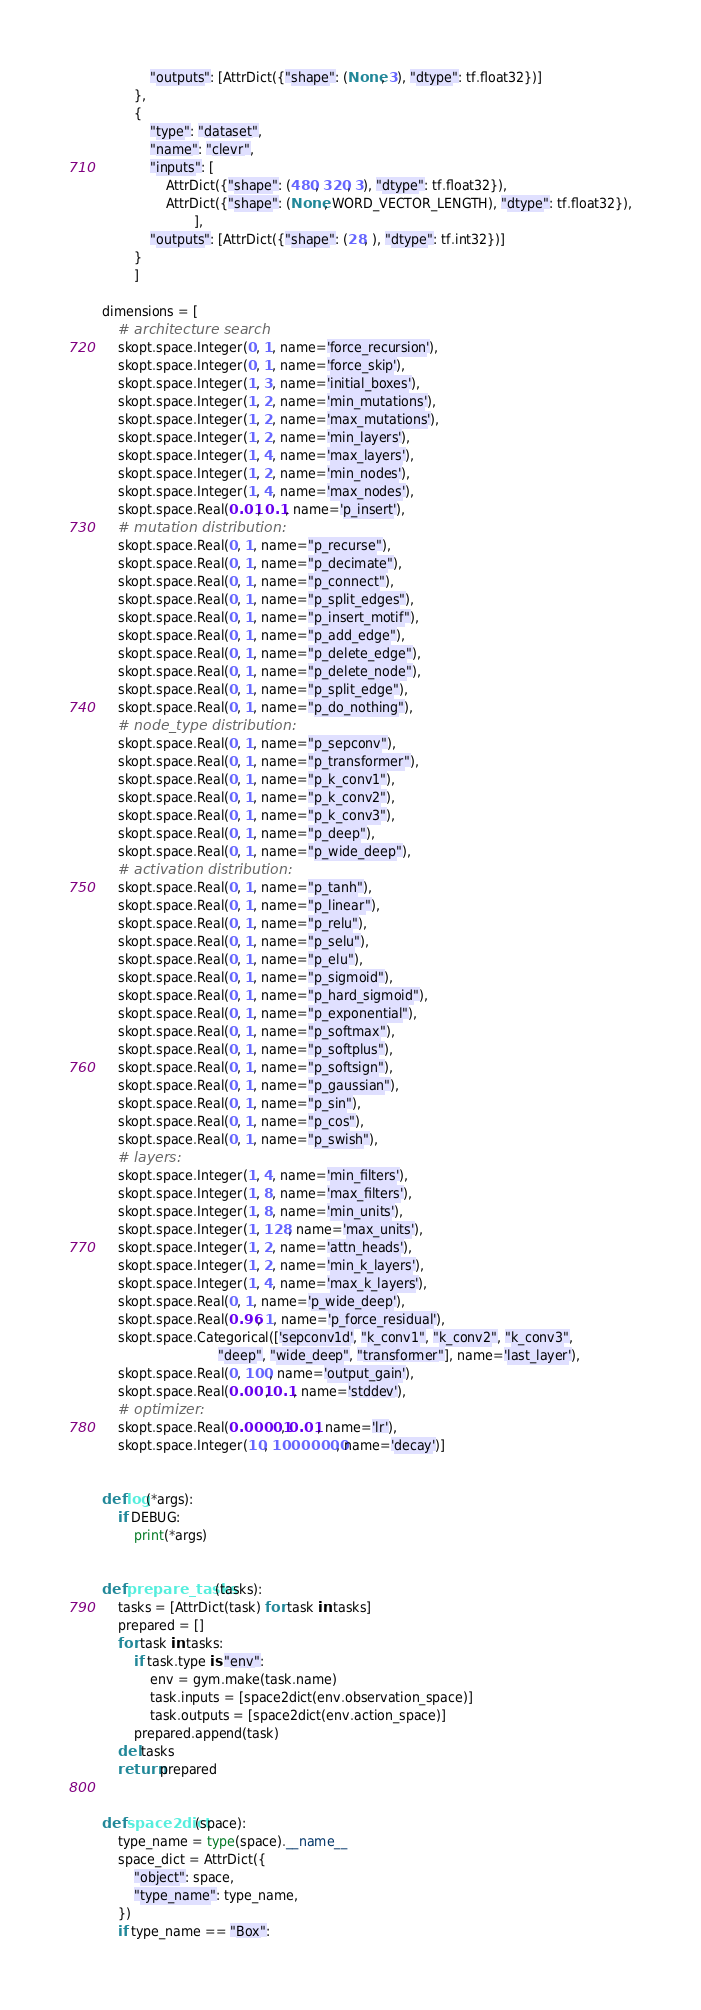<code> <loc_0><loc_0><loc_500><loc_500><_Python_>            "outputs": [AttrDict({"shape": (None, 3), "dtype": tf.float32})]
        },
        {
            "type": "dataset",
            "name": "clevr",
            "inputs": [
                AttrDict({"shape": (480, 320, 3), "dtype": tf.float32}),
                AttrDict({"shape": (None, WORD_VECTOR_LENGTH), "dtype": tf.float32}),
                       ],
            "outputs": [AttrDict({"shape": (28, ), "dtype": tf.int32})]
        }
        ]

dimensions = [
    # architecture search
    skopt.space.Integer(0, 1, name='force_recursion'),
    skopt.space.Integer(0, 1, name='force_skip'),
    skopt.space.Integer(1, 3, name='initial_boxes'),
    skopt.space.Integer(1, 2, name='min_mutations'),
    skopt.space.Integer(1, 2, name='max_mutations'),
    skopt.space.Integer(1, 2, name='min_layers'),
    skopt.space.Integer(1, 4, name='max_layers'),
    skopt.space.Integer(1, 2, name='min_nodes'),
    skopt.space.Integer(1, 4, name='max_nodes'),
    skopt.space.Real(0.01, 0.1, name='p_insert'),
    # mutation distribution:
    skopt.space.Real(0, 1, name="p_recurse"),
    skopt.space.Real(0, 1, name="p_decimate"),
    skopt.space.Real(0, 1, name="p_connect"),
    skopt.space.Real(0, 1, name="p_split_edges"),
    skopt.space.Real(0, 1, name="p_insert_motif"),
    skopt.space.Real(0, 1, name="p_add_edge"),
    skopt.space.Real(0, 1, name="p_delete_edge"),
    skopt.space.Real(0, 1, name="p_delete_node"),
    skopt.space.Real(0, 1, name="p_split_edge"),
    skopt.space.Real(0, 1, name="p_do_nothing"),
    # node_type distribution:
    skopt.space.Real(0, 1, name="p_sepconv"),
    skopt.space.Real(0, 1, name="p_transformer"),
    skopt.space.Real(0, 1, name="p_k_conv1"),
    skopt.space.Real(0, 1, name="p_k_conv2"),
    skopt.space.Real(0, 1, name="p_k_conv3"),
    skopt.space.Real(0, 1, name="p_deep"),
    skopt.space.Real(0, 1, name="p_wide_deep"),
    # activation distribution:
    skopt.space.Real(0, 1, name="p_tanh"),
    skopt.space.Real(0, 1, name="p_linear"),
    skopt.space.Real(0, 1, name="p_relu"),
    skopt.space.Real(0, 1, name="p_selu"),
    skopt.space.Real(0, 1, name="p_elu"),
    skopt.space.Real(0, 1, name="p_sigmoid"),
    skopt.space.Real(0, 1, name="p_hard_sigmoid"),
    skopt.space.Real(0, 1, name="p_exponential"),
    skopt.space.Real(0, 1, name="p_softmax"),
    skopt.space.Real(0, 1, name="p_softplus"),
    skopt.space.Real(0, 1, name="p_softsign"),
    skopt.space.Real(0, 1, name="p_gaussian"),
    skopt.space.Real(0, 1, name="p_sin"),
    skopt.space.Real(0, 1, name="p_cos"),
    skopt.space.Real(0, 1, name="p_swish"),
    # layers:
    skopt.space.Integer(1, 4, name='min_filters'),
    skopt.space.Integer(1, 8, name='max_filters'),
    skopt.space.Integer(1, 8, name='min_units'),
    skopt.space.Integer(1, 128, name='max_units'),
    skopt.space.Integer(1, 2, name='attn_heads'),
    skopt.space.Integer(1, 2, name='min_k_layers'),
    skopt.space.Integer(1, 4, name='max_k_layers'),
    skopt.space.Real(0, 1, name='p_wide_deep'),
    skopt.space.Real(0.96, 1, name='p_force_residual'),
    skopt.space.Categorical(['sepconv1d', "k_conv1", "k_conv2", "k_conv3",
                             "deep", "wide_deep", "transformer"], name='last_layer'),
    skopt.space.Real(0, 100, name='output_gain'),
    skopt.space.Real(0.001, 0.1, name='stddev'),
    # optimizer:
    skopt.space.Real(0.00001, 0.01, name='lr'),
    skopt.space.Integer(10, 10000000, name='decay')]


def log(*args):
    if DEBUG:
        print(*args)


def prepare_tasks(tasks):
    tasks = [AttrDict(task) for task in tasks]
    prepared = []
    for task in tasks:
        if task.type is "env":
            env = gym.make(task.name)
            task.inputs = [space2dict(env.observation_space)]
            task.outputs = [space2dict(env.action_space)]
        prepared.append(task)
    del tasks
    return prepared


def space2dict(space):
    type_name = type(space).__name__
    space_dict = AttrDict({
        "object": space,
        "type_name": type_name,
    })
    if type_name == "Box":</code> 